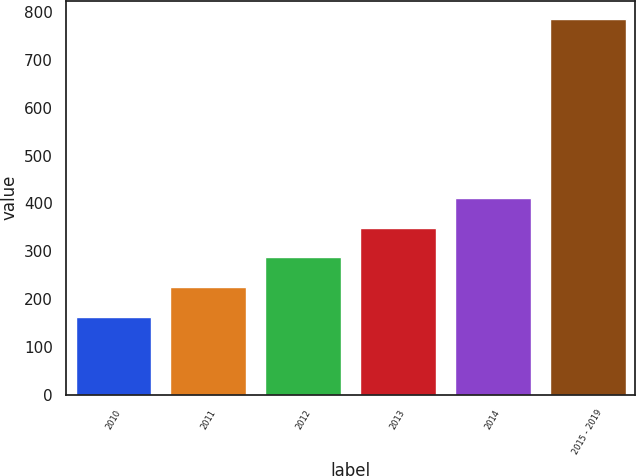<chart> <loc_0><loc_0><loc_500><loc_500><bar_chart><fcel>2010<fcel>2011<fcel>2012<fcel>2013<fcel>2014<fcel>2015 - 2019<nl><fcel>163<fcel>225.2<fcel>287.4<fcel>349.6<fcel>411.8<fcel>785<nl></chart> 